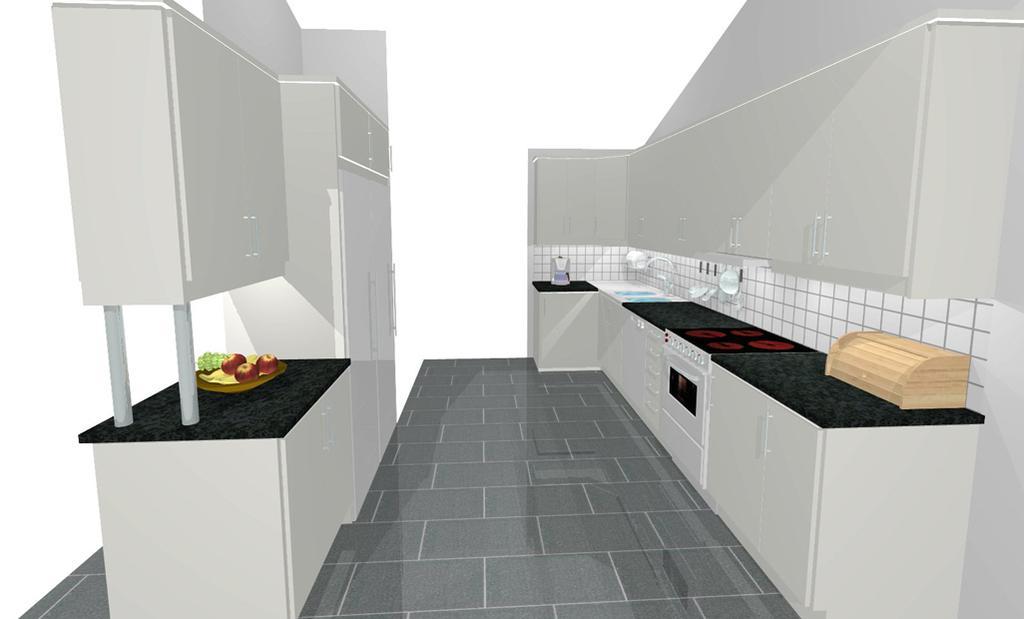Please provide a concise description of this image. This image is an animation. In this image we can see countertops and there are things placed on the counter tops. On the left there are fruits placed on the stand. We can see cupboards. In the background there is a wall. At the bottom we can see the floor. 